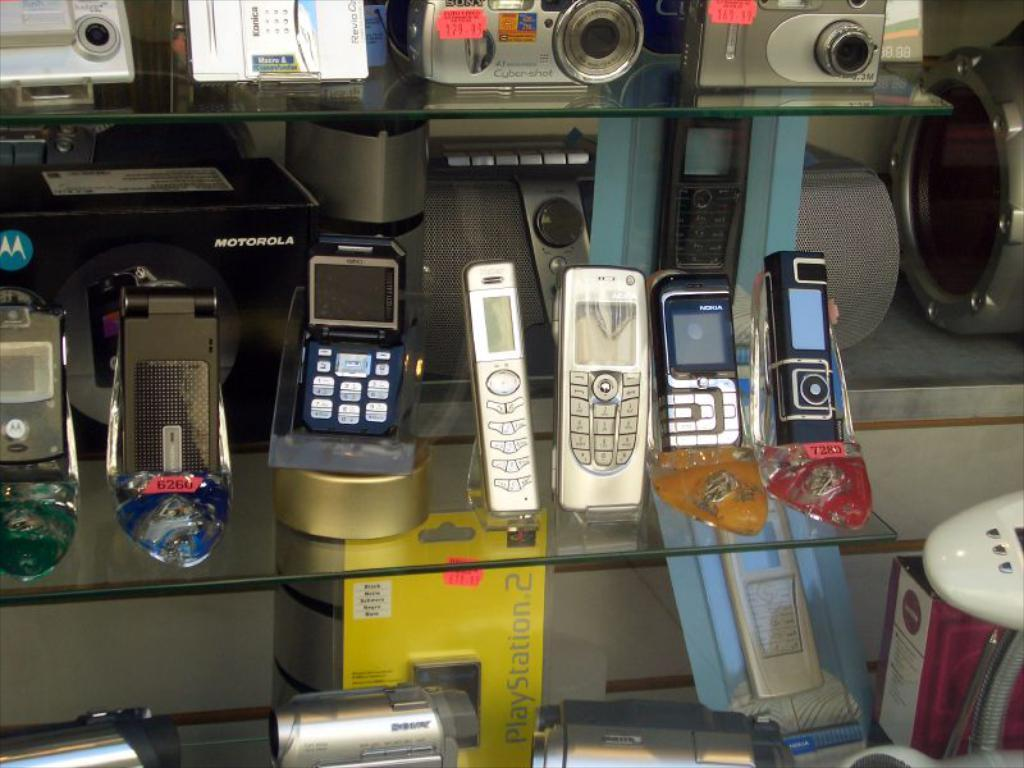<image>
Create a compact narrative representing the image presented. a yellow box that has the words play station 2 on it 